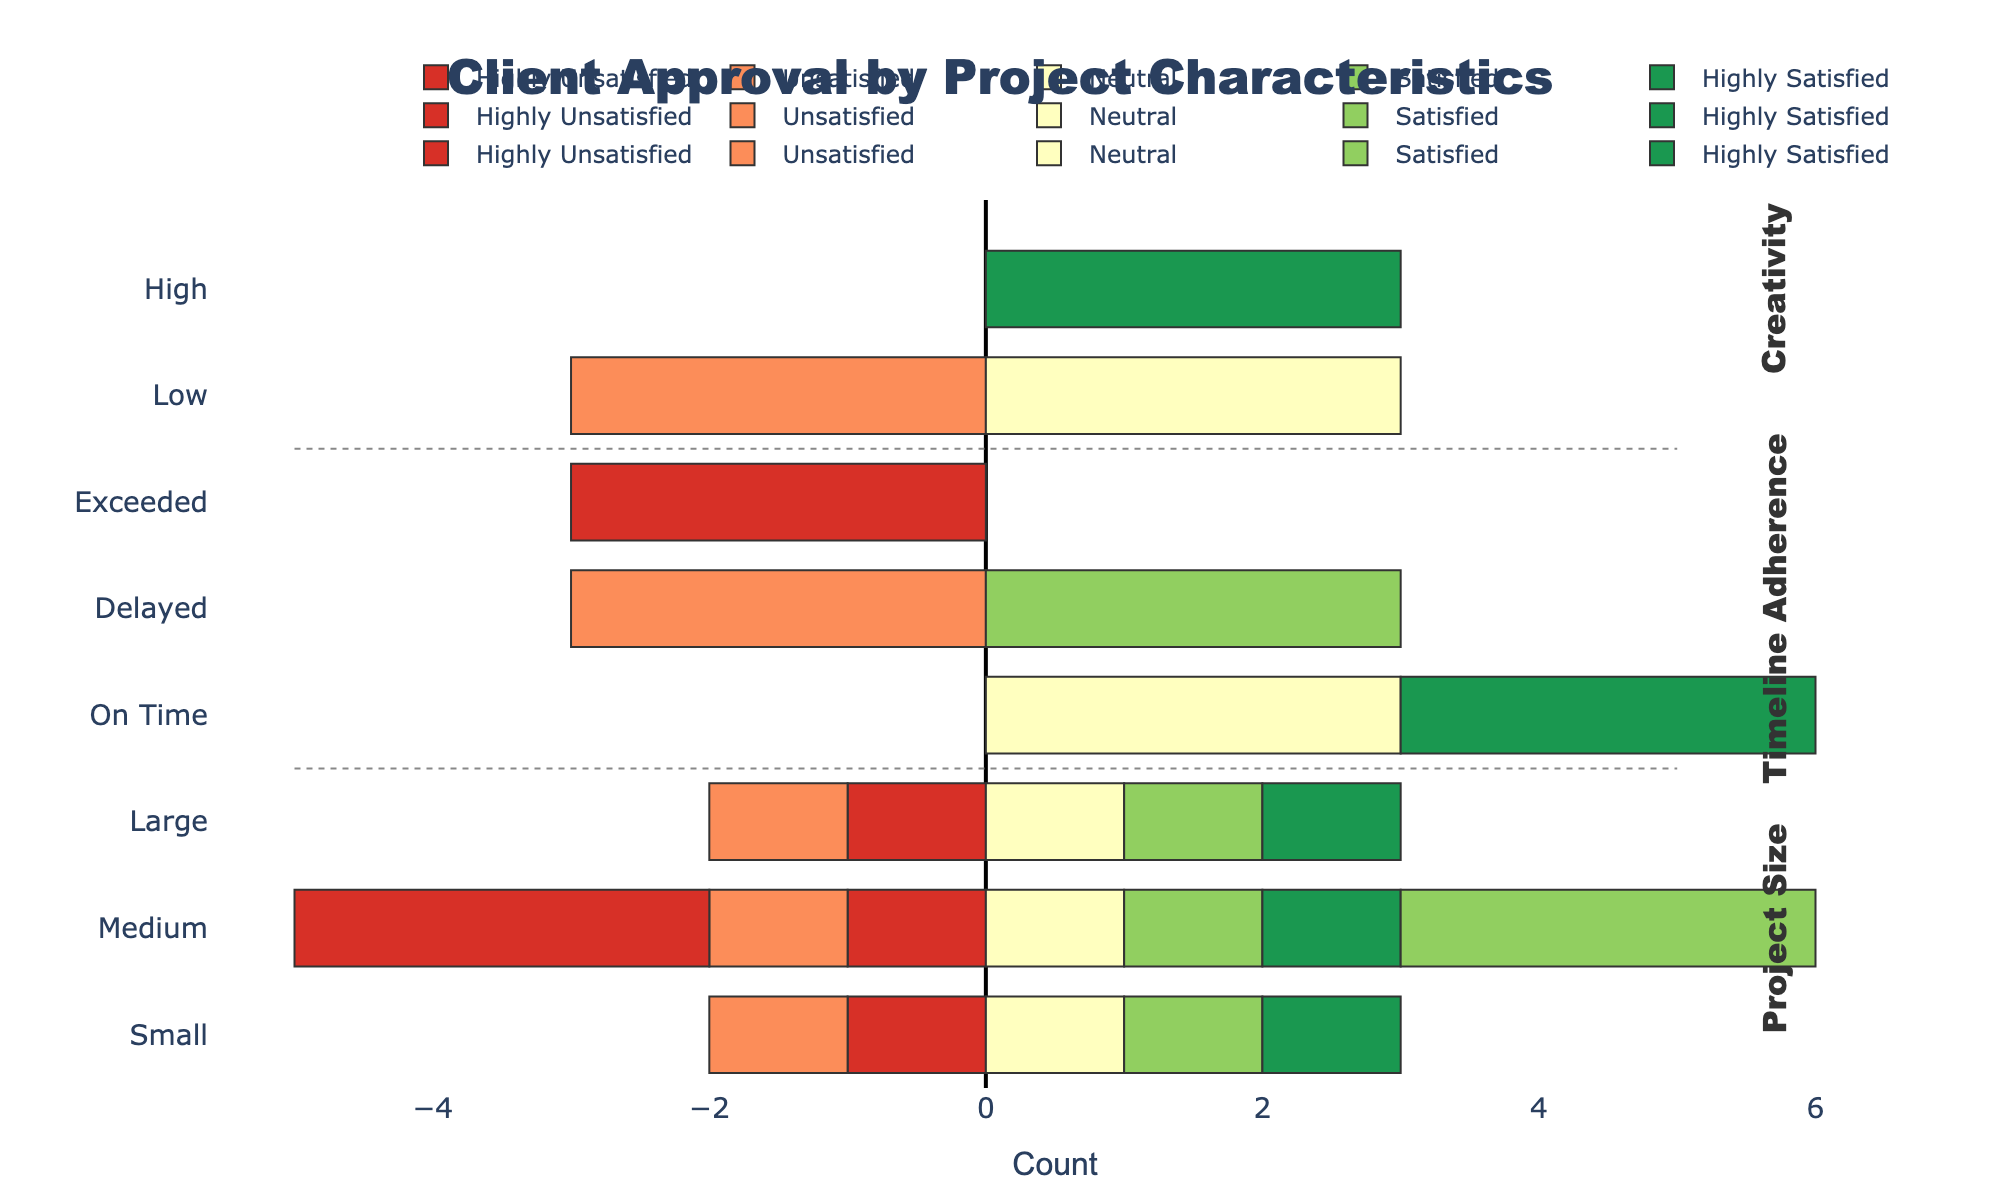Which project size has the highest number of highly satisfied clients? Look at the bars labeled 'Highly Satisfied' for each project size. The longest bar represents the highest number. For 'Highly Satisfied', the project sizes are Small, Medium, and Large. Among these, the bar for Small is the longest.
Answer: Small How does the number of satisfied clients compare between Medium and Large project sizes? Compare the lengths of the 'Satisfied' bars for Medium and Large project sizes. Count the number of clients or visually compare the length. The bar for Medium is longer than for Large.
Answer: Medium has more Which aspect, project size, timeline adherence, or creativity, shows the highest dissatisfaction (unsatisfied + highly unsatisfied)? Compare the lengths of the 'Unsatisfied' and 'Highly Unsatisfied' bars in each category. Sum the lengths visually or count the total. Creativity has longer bars for 'Unsatisfied' and 'Highly Unsatisfied'.
Answer: Creativity What is the visual difference in client approval for projects completed on time versus those delayed? Compare the bars under 'On Time' and 'Delayed' for all approval levels. 'On Time' has longer positive bars (Highly Satisfied and Satisfied) while 'Delayed' has longer negative bars (Unsatisfied and Highly Unsatisfied).
Answer: On Time has higher satisfaction Which category, timeline adherence or creativity, has a more significant neutral client approval rating? Look at the 'Neutral' bars under 'Timeline Adherence' and 'Creativity'. Compare their lengths. The 'Neutral' bar under 'Creativity' is longer.
Answer: Creativity How many more highly unsatisfied clients are there for large projects compared to small projects? Count the length of the 'Highly Unsatisfied' bars for both Large and Small project sizes. Large has 1, Small has 1. The difference is 0.
Answer: 0 Which timeline adherence category has the highest positive client approval? Among 'On Time', 'Delayed', and 'Exceeded', check which has the longest bars for 'Highly Satisfied' and 'Satisfied'. 'On Time' has the longest bars.
Answer: On Time Are there more satisfied or neutral clients for medium-sized projects? Compare lengths of 'Satisfied' and 'Neutral' bars under Medium project size. 'Satisfied' is longer than 'Neutral'.
Answer: Satisfied What is the general trend in client satisfaction as creativity increases from low to high? Observe the change in bar lengths for each satisfaction level (highly satisfied to highly unsatisfied) as you move from Low to High creativity categories. Satisfaction increases with creativity, indicated by increasing lengths of 'Highly Satisfied' and 'Satisfied' bars and decreasing lengths of 'Highly Unsatisfied' and 'Unsatisfied' bars.
Answer: Increases Which approval rating is more prevalent for projects that exceed their timeline, satisfied or highly unsatisfied? Compare the 'Satisfied' and 'Highly Unsatisfied' bars under the 'Exceeded' category. The 'Highly Unsatisfied' bar is longer.
Answer: Highly Unsatisfied 